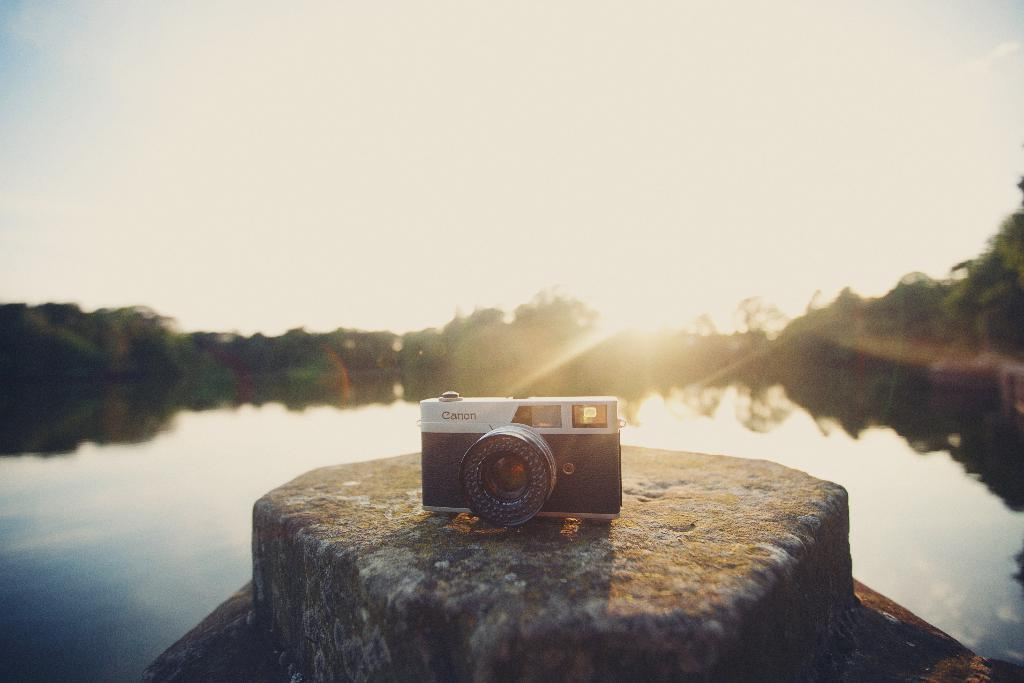What is the main subject of the image? There is a huge rock in the image. What is placed on the rock? A camera is present on the rock. Can you describe the color of the camera? The camera is white and black in color. What can be seen in the background of the image? There is water, trees, and the sky visible in the background of the image. Is the sun visible in the sky? Yes, the sun is observable in the sky. What type of paint is being used by the bushes in the image? There are no bushes present in the image, and therefore no paint can be associated with them. What emotion is the regret feeling in the image? There is no emotion or feeling of regret depicted in the image. 